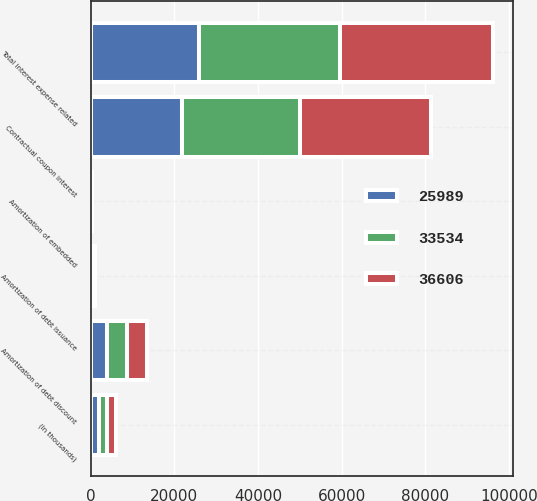Convert chart to OTSL. <chart><loc_0><loc_0><loc_500><loc_500><stacked_bar_chart><ecel><fcel>(In thousands)<fcel>Contractual coupon interest<fcel>Amortization of debt issuance<fcel>Amortization of embedded<fcel>Amortization of debt discount<fcel>Total interest expense related<nl><fcel>25989<fcel>2010<fcel>21816<fcel>223<fcel>58<fcel>3892<fcel>25989<nl><fcel>33534<fcel>2009<fcel>28293<fcel>379<fcel>73<fcel>4789<fcel>33534<nl><fcel>36606<fcel>2008<fcel>31250<fcel>383<fcel>84<fcel>4889<fcel>36606<nl></chart> 